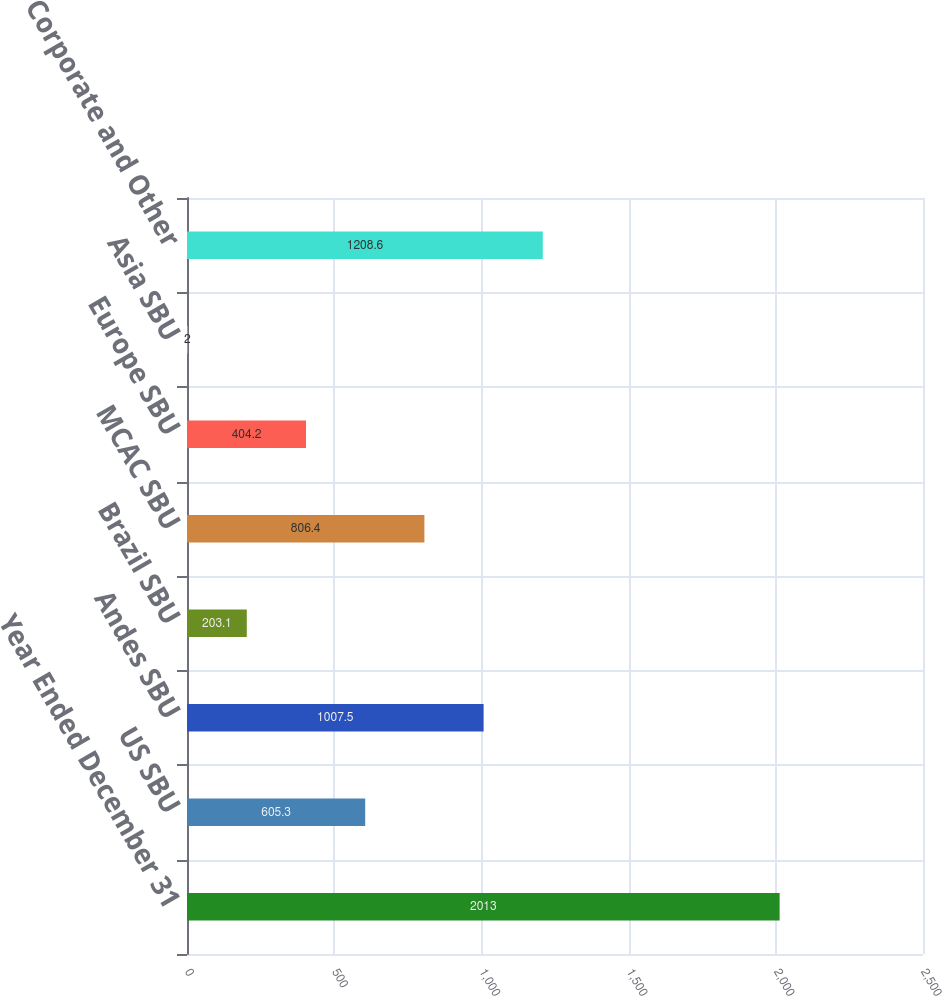Convert chart. <chart><loc_0><loc_0><loc_500><loc_500><bar_chart><fcel>Year Ended December 31<fcel>US SBU<fcel>Andes SBU<fcel>Brazil SBU<fcel>MCAC SBU<fcel>Europe SBU<fcel>Asia SBU<fcel>Corporate and Other<nl><fcel>2013<fcel>605.3<fcel>1007.5<fcel>203.1<fcel>806.4<fcel>404.2<fcel>2<fcel>1208.6<nl></chart> 